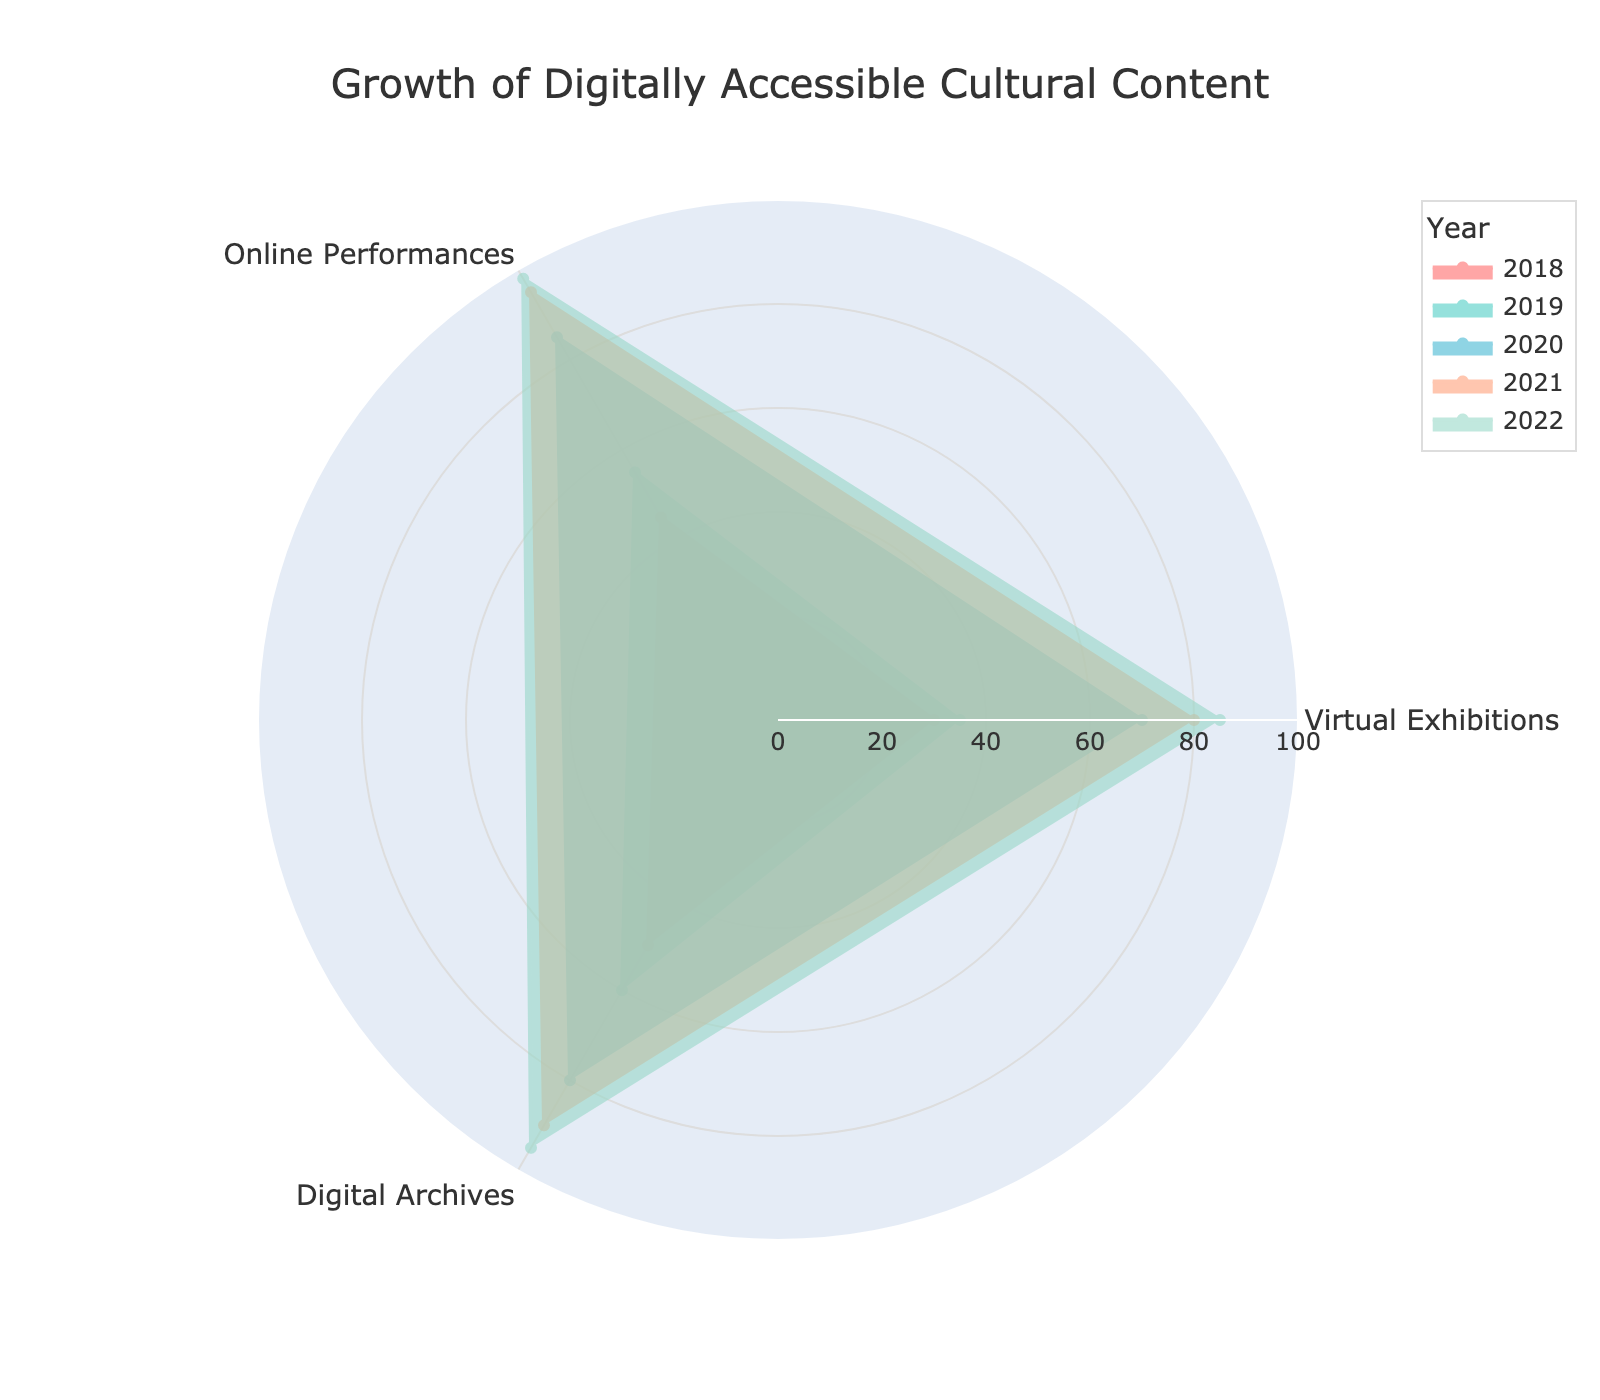What's the highest value recorded for Online Performances? The highest value can be observed by looking at the outermost point on the Online Performances axis. In the figure, this corresponds to 2022, where the value for Online Performances is 98.
Answer: 98 Which year shows the lowest value for Digital Archives? The lowest value for Digital Archives can be determined by examining the innermost point on the Digital Archives axis. The year corresponding to this value is 2018, where the value is 50.
Answer: 2018 What is the average growth of Virtual Exhibitions from 2018 to 2022? To calculate the average growth, sum the values of Virtual Exhibitions from each year (30, 35, 70, 80, 85) and divide by the number of years (5). This comes to (30 + 35 + 70 + 80 + 85) / 5 = 300 / 5 = 60.
Answer: 60 Between which two consecutive years did Online Performances see the greatest increase? Compute the yearly increments and compare: 
  - 2018 to 2019: 55 - 45 = 10
  - 2019 to 2020: 85 - 55 = 30
  - 2020 to 2021: 95 - 85 = 10
  - 2021 to 2022: 98 - 95 = 3
  The greatest increase happened between 2019 and 2020.
Answer: 2019 to 2020 What is the general trend of growth for all three categories from 2018 to 2022? By observing the radar chart, each category shows a generally increasing trend from 2018 to 2022, indicated by progressively expanding areas outward.
Answer: Increasing Which category had the most consistent growth every year? To determine consistency, examine year-on-year increments for each category:
  - Virtual Exhibitions: +5, +35, +10, +5
  - Online Performances: +10, +30, +10, +3
  - Digital Archives: +10, +20, +10, +5
  The increasements for each category indicate Digital Archives had the most consistent growth.
Answer: Digital Archives Which year had the highest overall digital cultural content growth? By visually summing the distances from the center to the outer edges for each year, 2022 shows the highest overall growth with the largest enclosed area in the radar chart.
Answer: 2022 Between 2020 and 2021, which category experienced the highest growth? Comparing the year-on-year changes:
  - Virtual Exhibitions: 80 - 70 = 10
  - Online Performances: 95 - 85 = 10
  - Digital Archives: 90 - 80 = 10
  All three categories experienced the same growth of 10 units between 2020 and 2021.
Answer: All categories (10 units) What was the percentage growth of Digital Archives from 2019 to 2020? Percentage growth is calculated by the increase divided by the initial value times 100. From 2019 to 2020, Digital Archives grew from 60 to 80:
  Percentage growth = ((80 - 60) / 60) * 100 = (20 / 60) * 100 = 33.33%.
Answer: 33.33% 